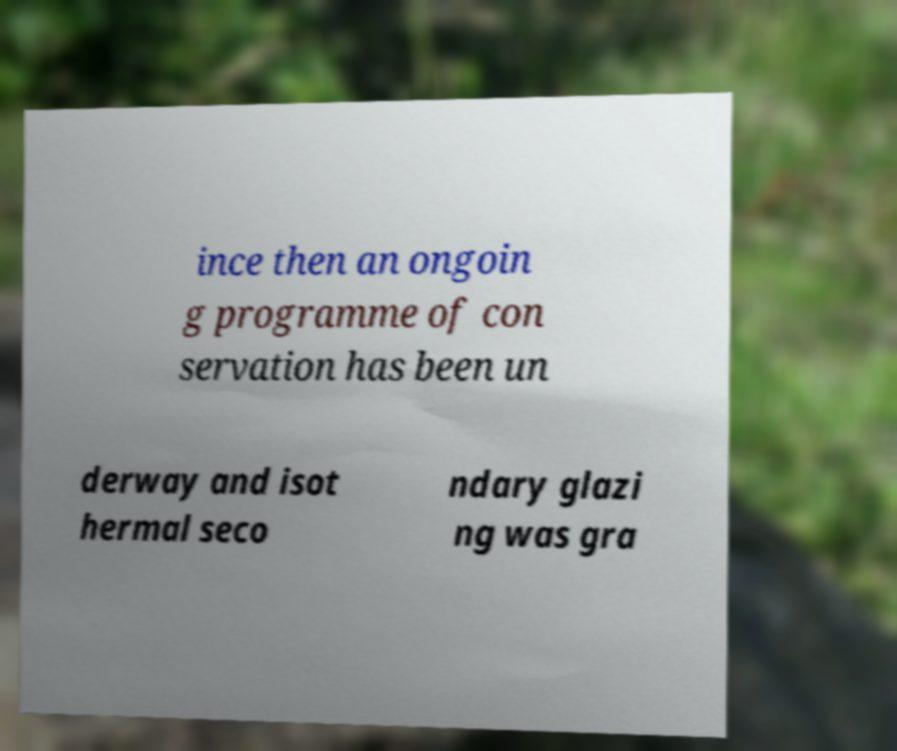Can you accurately transcribe the text from the provided image for me? ince then an ongoin g programme of con servation has been un derway and isot hermal seco ndary glazi ng was gra 